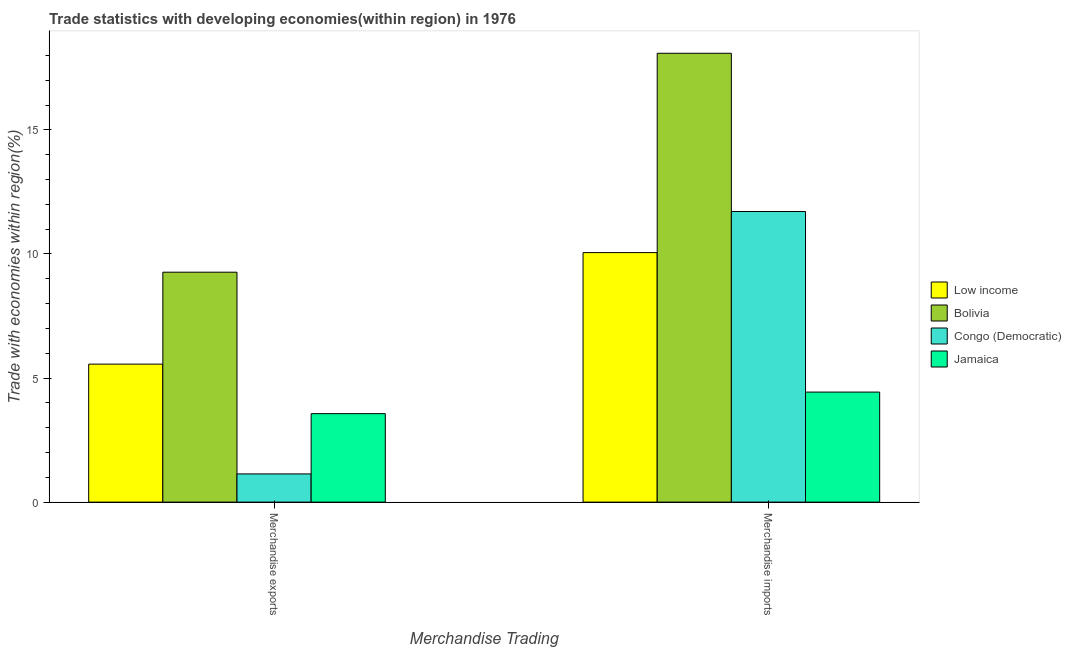How many bars are there on the 1st tick from the right?
Provide a short and direct response. 4. What is the merchandise imports in Low income?
Make the answer very short. 10.05. Across all countries, what is the maximum merchandise imports?
Make the answer very short. 18.09. Across all countries, what is the minimum merchandise imports?
Your answer should be very brief. 4.43. In which country was the merchandise exports minimum?
Your answer should be compact. Congo (Democratic). What is the total merchandise exports in the graph?
Offer a very short reply. 19.53. What is the difference between the merchandise imports in Jamaica and that in Low income?
Your answer should be compact. -5.62. What is the difference between the merchandise exports in Bolivia and the merchandise imports in Jamaica?
Offer a terse response. 4.83. What is the average merchandise imports per country?
Give a very brief answer. 11.07. What is the difference between the merchandise imports and merchandise exports in Bolivia?
Make the answer very short. 8.82. What is the ratio of the merchandise exports in Low income to that in Congo (Democratic)?
Offer a very short reply. 4.89. In how many countries, is the merchandise imports greater than the average merchandise imports taken over all countries?
Your answer should be compact. 2. What does the 3rd bar from the left in Merchandise imports represents?
Offer a terse response. Congo (Democratic). What does the 2nd bar from the right in Merchandise exports represents?
Provide a succinct answer. Congo (Democratic). Are all the bars in the graph horizontal?
Keep it short and to the point. No. How many countries are there in the graph?
Give a very brief answer. 4. What is the difference between two consecutive major ticks on the Y-axis?
Give a very brief answer. 5. Are the values on the major ticks of Y-axis written in scientific E-notation?
Your answer should be compact. No. Does the graph contain any zero values?
Your response must be concise. No. Where does the legend appear in the graph?
Keep it short and to the point. Center right. How are the legend labels stacked?
Give a very brief answer. Vertical. What is the title of the graph?
Your answer should be very brief. Trade statistics with developing economies(within region) in 1976. Does "St. Vincent and the Grenadines" appear as one of the legend labels in the graph?
Make the answer very short. No. What is the label or title of the X-axis?
Make the answer very short. Merchandise Trading. What is the label or title of the Y-axis?
Your response must be concise. Trade with economies within region(%). What is the Trade with economies within region(%) of Low income in Merchandise exports?
Your answer should be compact. 5.56. What is the Trade with economies within region(%) of Bolivia in Merchandise exports?
Offer a terse response. 9.27. What is the Trade with economies within region(%) of Congo (Democratic) in Merchandise exports?
Keep it short and to the point. 1.14. What is the Trade with economies within region(%) in Jamaica in Merchandise exports?
Make the answer very short. 3.57. What is the Trade with economies within region(%) of Low income in Merchandise imports?
Your answer should be very brief. 10.05. What is the Trade with economies within region(%) in Bolivia in Merchandise imports?
Ensure brevity in your answer.  18.09. What is the Trade with economies within region(%) of Congo (Democratic) in Merchandise imports?
Offer a very short reply. 11.71. What is the Trade with economies within region(%) of Jamaica in Merchandise imports?
Provide a short and direct response. 4.43. Across all Merchandise Trading, what is the maximum Trade with economies within region(%) of Low income?
Keep it short and to the point. 10.05. Across all Merchandise Trading, what is the maximum Trade with economies within region(%) of Bolivia?
Offer a terse response. 18.09. Across all Merchandise Trading, what is the maximum Trade with economies within region(%) of Congo (Democratic)?
Offer a terse response. 11.71. Across all Merchandise Trading, what is the maximum Trade with economies within region(%) of Jamaica?
Your answer should be compact. 4.43. Across all Merchandise Trading, what is the minimum Trade with economies within region(%) of Low income?
Ensure brevity in your answer.  5.56. Across all Merchandise Trading, what is the minimum Trade with economies within region(%) in Bolivia?
Provide a succinct answer. 9.27. Across all Merchandise Trading, what is the minimum Trade with economies within region(%) in Congo (Democratic)?
Offer a very short reply. 1.14. Across all Merchandise Trading, what is the minimum Trade with economies within region(%) of Jamaica?
Offer a very short reply. 3.57. What is the total Trade with economies within region(%) of Low income in the graph?
Offer a very short reply. 15.62. What is the total Trade with economies within region(%) of Bolivia in the graph?
Ensure brevity in your answer.  27.35. What is the total Trade with economies within region(%) in Congo (Democratic) in the graph?
Offer a very short reply. 12.85. What is the total Trade with economies within region(%) of Jamaica in the graph?
Provide a succinct answer. 8. What is the difference between the Trade with economies within region(%) in Low income in Merchandise exports and that in Merchandise imports?
Offer a very short reply. -4.49. What is the difference between the Trade with economies within region(%) in Bolivia in Merchandise exports and that in Merchandise imports?
Make the answer very short. -8.82. What is the difference between the Trade with economies within region(%) in Congo (Democratic) in Merchandise exports and that in Merchandise imports?
Offer a very short reply. -10.57. What is the difference between the Trade with economies within region(%) of Jamaica in Merchandise exports and that in Merchandise imports?
Ensure brevity in your answer.  -0.87. What is the difference between the Trade with economies within region(%) of Low income in Merchandise exports and the Trade with economies within region(%) of Bolivia in Merchandise imports?
Your answer should be very brief. -12.53. What is the difference between the Trade with economies within region(%) in Low income in Merchandise exports and the Trade with economies within region(%) in Congo (Democratic) in Merchandise imports?
Provide a succinct answer. -6.15. What is the difference between the Trade with economies within region(%) of Low income in Merchandise exports and the Trade with economies within region(%) of Jamaica in Merchandise imports?
Offer a terse response. 1.13. What is the difference between the Trade with economies within region(%) of Bolivia in Merchandise exports and the Trade with economies within region(%) of Congo (Democratic) in Merchandise imports?
Your response must be concise. -2.44. What is the difference between the Trade with economies within region(%) in Bolivia in Merchandise exports and the Trade with economies within region(%) in Jamaica in Merchandise imports?
Keep it short and to the point. 4.83. What is the difference between the Trade with economies within region(%) of Congo (Democratic) in Merchandise exports and the Trade with economies within region(%) of Jamaica in Merchandise imports?
Offer a very short reply. -3.3. What is the average Trade with economies within region(%) of Low income per Merchandise Trading?
Your response must be concise. 7.81. What is the average Trade with economies within region(%) of Bolivia per Merchandise Trading?
Your answer should be very brief. 13.68. What is the average Trade with economies within region(%) in Congo (Democratic) per Merchandise Trading?
Make the answer very short. 6.42. What is the average Trade with economies within region(%) of Jamaica per Merchandise Trading?
Make the answer very short. 4. What is the difference between the Trade with economies within region(%) in Low income and Trade with economies within region(%) in Bolivia in Merchandise exports?
Ensure brevity in your answer.  -3.7. What is the difference between the Trade with economies within region(%) in Low income and Trade with economies within region(%) in Congo (Democratic) in Merchandise exports?
Make the answer very short. 4.42. What is the difference between the Trade with economies within region(%) of Low income and Trade with economies within region(%) of Jamaica in Merchandise exports?
Your response must be concise. 2. What is the difference between the Trade with economies within region(%) of Bolivia and Trade with economies within region(%) of Congo (Democratic) in Merchandise exports?
Your response must be concise. 8.13. What is the difference between the Trade with economies within region(%) in Congo (Democratic) and Trade with economies within region(%) in Jamaica in Merchandise exports?
Ensure brevity in your answer.  -2.43. What is the difference between the Trade with economies within region(%) in Low income and Trade with economies within region(%) in Bolivia in Merchandise imports?
Your answer should be very brief. -8.03. What is the difference between the Trade with economies within region(%) in Low income and Trade with economies within region(%) in Congo (Democratic) in Merchandise imports?
Your answer should be compact. -1.66. What is the difference between the Trade with economies within region(%) in Low income and Trade with economies within region(%) in Jamaica in Merchandise imports?
Offer a very short reply. 5.62. What is the difference between the Trade with economies within region(%) in Bolivia and Trade with economies within region(%) in Congo (Democratic) in Merchandise imports?
Offer a terse response. 6.38. What is the difference between the Trade with economies within region(%) in Bolivia and Trade with economies within region(%) in Jamaica in Merchandise imports?
Provide a short and direct response. 13.65. What is the difference between the Trade with economies within region(%) in Congo (Democratic) and Trade with economies within region(%) in Jamaica in Merchandise imports?
Provide a succinct answer. 7.28. What is the ratio of the Trade with economies within region(%) in Low income in Merchandise exports to that in Merchandise imports?
Give a very brief answer. 0.55. What is the ratio of the Trade with economies within region(%) in Bolivia in Merchandise exports to that in Merchandise imports?
Ensure brevity in your answer.  0.51. What is the ratio of the Trade with economies within region(%) in Congo (Democratic) in Merchandise exports to that in Merchandise imports?
Provide a short and direct response. 0.1. What is the ratio of the Trade with economies within region(%) of Jamaica in Merchandise exports to that in Merchandise imports?
Your response must be concise. 0.8. What is the difference between the highest and the second highest Trade with economies within region(%) of Low income?
Offer a very short reply. 4.49. What is the difference between the highest and the second highest Trade with economies within region(%) of Bolivia?
Keep it short and to the point. 8.82. What is the difference between the highest and the second highest Trade with economies within region(%) of Congo (Democratic)?
Give a very brief answer. 10.57. What is the difference between the highest and the second highest Trade with economies within region(%) in Jamaica?
Your answer should be very brief. 0.87. What is the difference between the highest and the lowest Trade with economies within region(%) of Low income?
Offer a terse response. 4.49. What is the difference between the highest and the lowest Trade with economies within region(%) of Bolivia?
Keep it short and to the point. 8.82. What is the difference between the highest and the lowest Trade with economies within region(%) in Congo (Democratic)?
Your response must be concise. 10.57. What is the difference between the highest and the lowest Trade with economies within region(%) in Jamaica?
Make the answer very short. 0.87. 